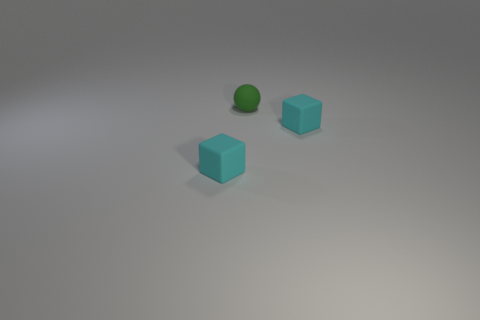There is a rubber object that is right of the tiny matte ball; does it have the same color as the ball?
Provide a short and direct response. No. Is there a object that is to the right of the small cyan matte block to the left of the ball?
Give a very brief answer. Yes. There is a cyan block right of the small thing that is on the left side of the small green matte thing; how big is it?
Your answer should be compact. Small. How many tiny cyan objects have the same shape as the tiny green matte thing?
Offer a very short reply. 0. Is there any other thing that is the same shape as the green thing?
Offer a very short reply. No. Is there another tiny rubber ball of the same color as the small sphere?
Offer a very short reply. No. Do the small cyan object to the left of the tiny ball and the thing right of the green matte ball have the same material?
Your answer should be compact. Yes. What color is the ball?
Your answer should be very brief. Green. There is a cyan cube on the left side of the small cyan matte cube that is behind the tiny cyan object that is to the left of the green ball; what size is it?
Your answer should be compact. Small. How many other things are there of the same size as the green matte ball?
Provide a short and direct response. 2. 